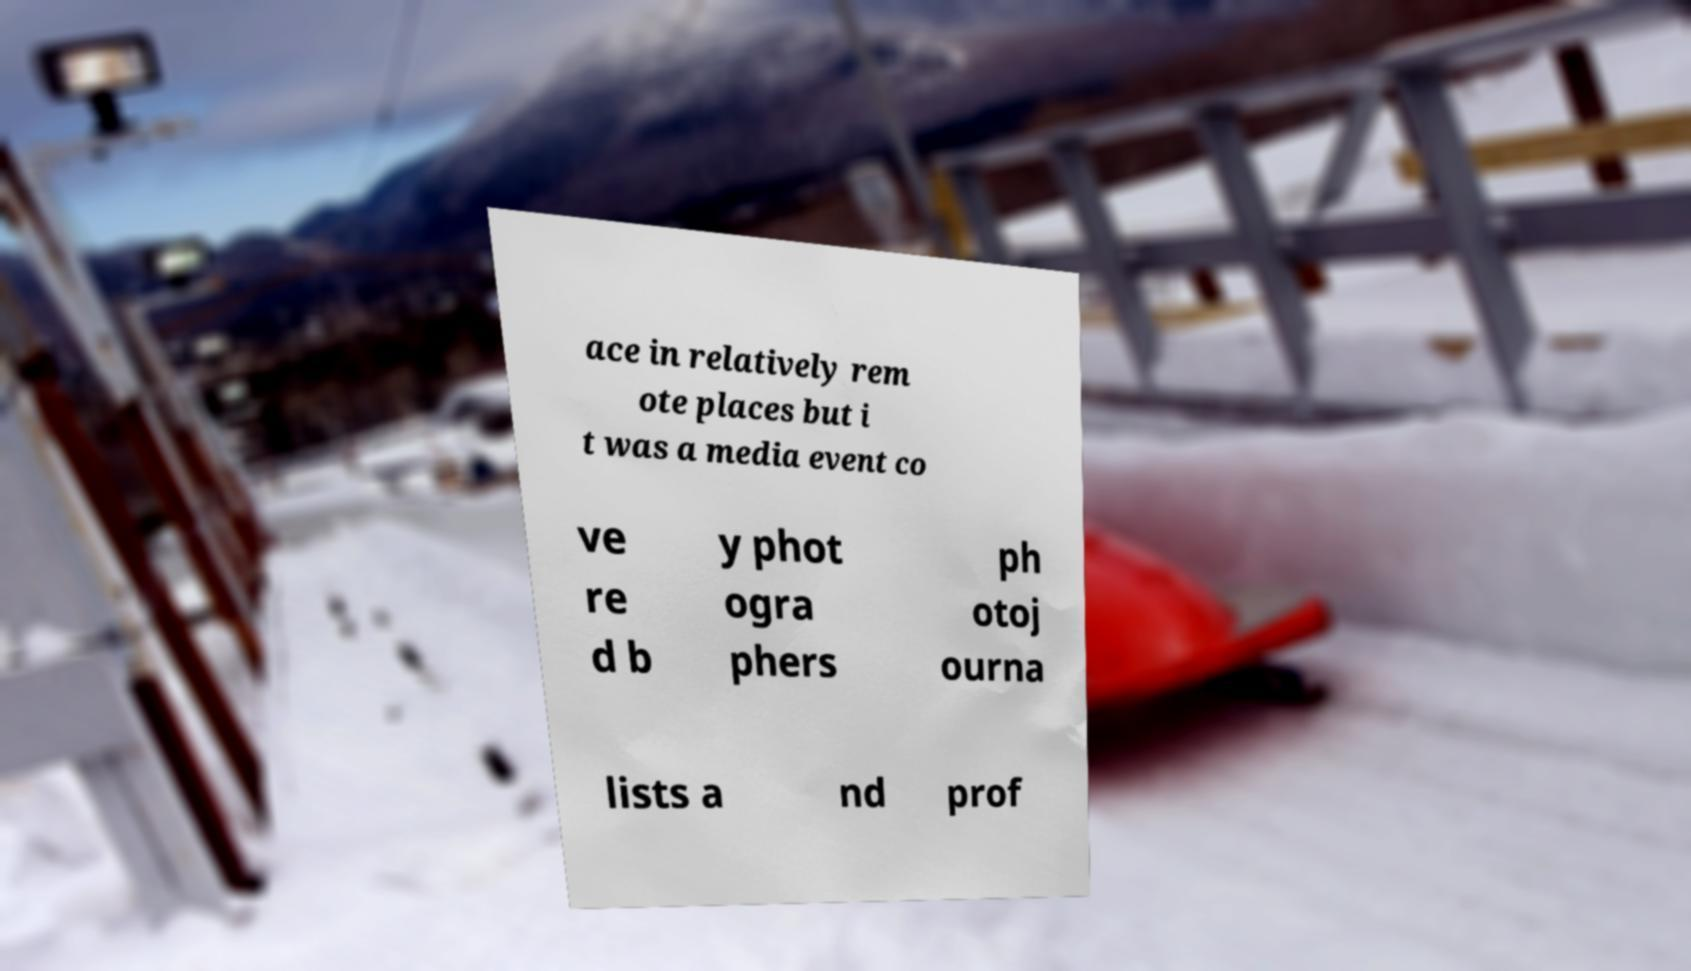Please identify and transcribe the text found in this image. ace in relatively rem ote places but i t was a media event co ve re d b y phot ogra phers ph otoj ourna lists a nd prof 